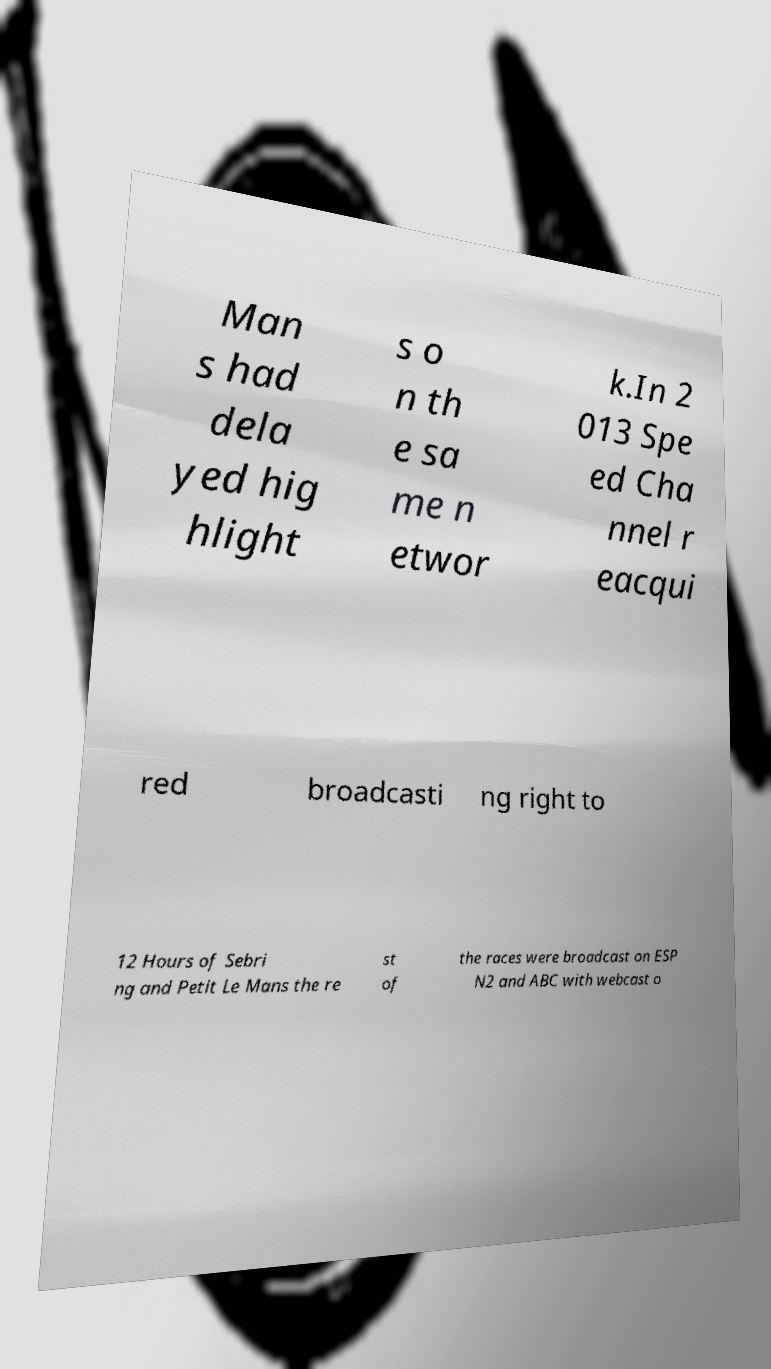Could you assist in decoding the text presented in this image and type it out clearly? Man s had dela yed hig hlight s o n th e sa me n etwor k.In 2 013 Spe ed Cha nnel r eacqui red broadcasti ng right to 12 Hours of Sebri ng and Petit Le Mans the re st of the races were broadcast on ESP N2 and ABC with webcast o 